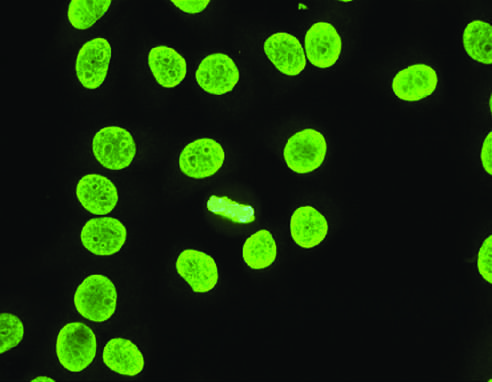re the photomicrographs typical of antibodies reactive with dsdna, nucleosomes, and histones?
Answer the question using a single word or phrase. No 